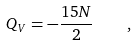<formula> <loc_0><loc_0><loc_500><loc_500>Q _ { V } = - \frac { 1 5 N } { 2 } \quad ,</formula> 